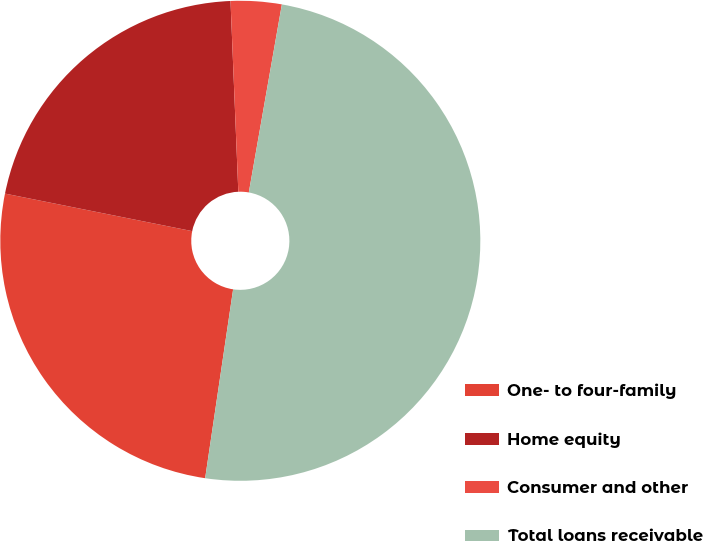Convert chart. <chart><loc_0><loc_0><loc_500><loc_500><pie_chart><fcel>One- to four-family<fcel>Home equity<fcel>Consumer and other<fcel>Total loans receivable<nl><fcel>25.81%<fcel>21.2%<fcel>3.42%<fcel>49.57%<nl></chart> 